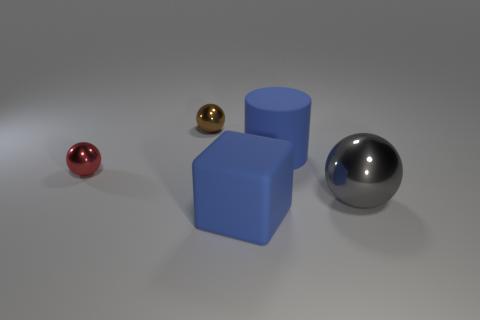There is a large block that is the same color as the large matte cylinder; what is its material?
Offer a terse response. Rubber. Do the large rubber cylinder and the tiny metallic thing on the left side of the tiny brown metallic sphere have the same color?
Make the answer very short. No. Are there more blue rubber cylinders than big blue objects?
Make the answer very short. No. What is the size of the red metal object that is the same shape as the large gray metal thing?
Ensure brevity in your answer.  Small. Is the material of the blue block the same as the large blue cylinder to the right of the matte block?
Offer a very short reply. Yes. How many things are large gray blocks or small objects?
Your response must be concise. 2. There is a shiny object to the left of the brown thing; is it the same size as the metallic object that is on the right side of the brown ball?
Give a very brief answer. No. How many cylinders are large gray things or large green objects?
Your response must be concise. 0. Are any red objects visible?
Keep it short and to the point. Yes. Is there any other thing that has the same shape as the brown object?
Ensure brevity in your answer.  Yes. 